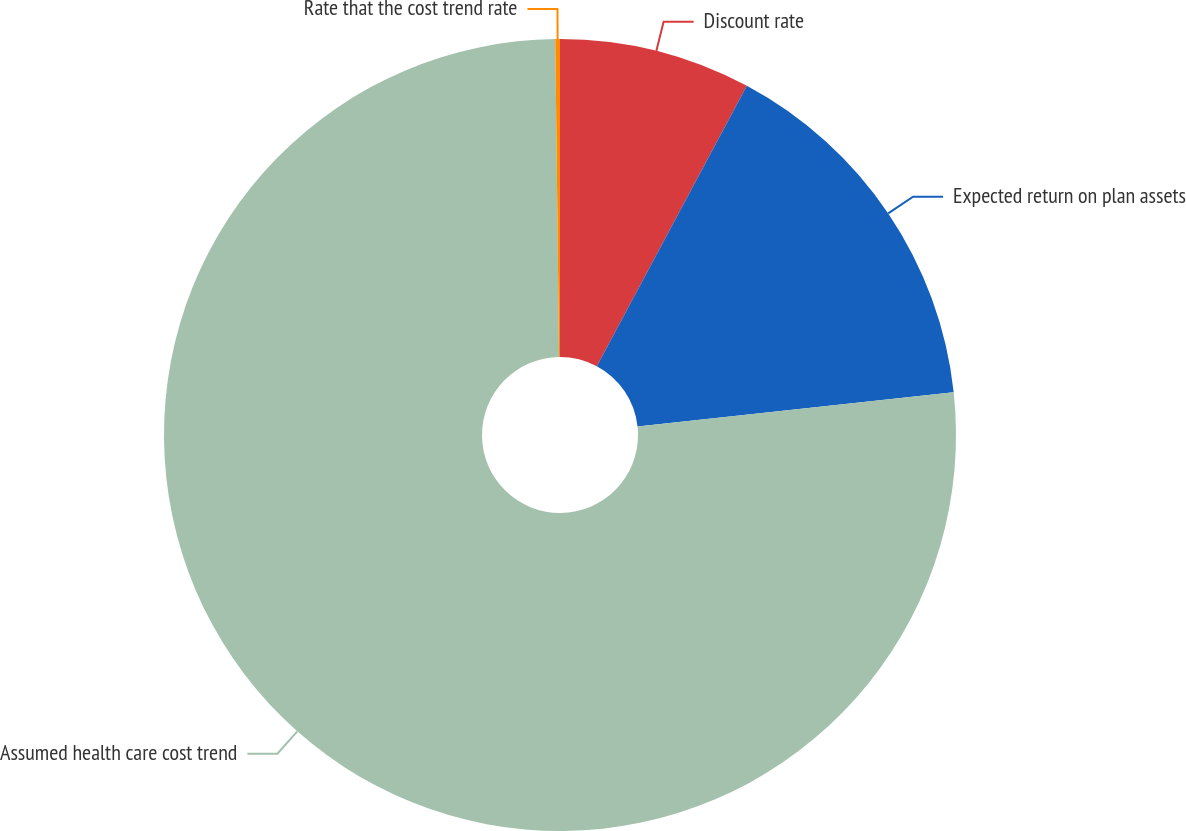<chart> <loc_0><loc_0><loc_500><loc_500><pie_chart><fcel>Discount rate<fcel>Expected return on plan assets<fcel>Assumed health care cost trend<fcel>Rate that the cost trend rate<nl><fcel>7.82%<fcel>15.46%<fcel>76.53%<fcel>0.19%<nl></chart> 